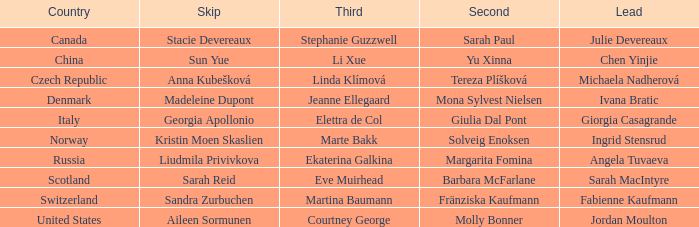What leap has switzerland as the country? Sandra Zurbuchen. 